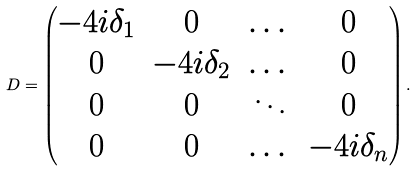<formula> <loc_0><loc_0><loc_500><loc_500>D = \begin{pmatrix} - 4 i \delta _ { 1 } & 0 & \dots & 0 \\ 0 & - 4 i \delta _ { 2 } & \dots & 0 \\ 0 & 0 & \ddots & 0 \\ 0 & 0 & \dots & - 4 i \delta _ { n } \end{pmatrix} .</formula> 